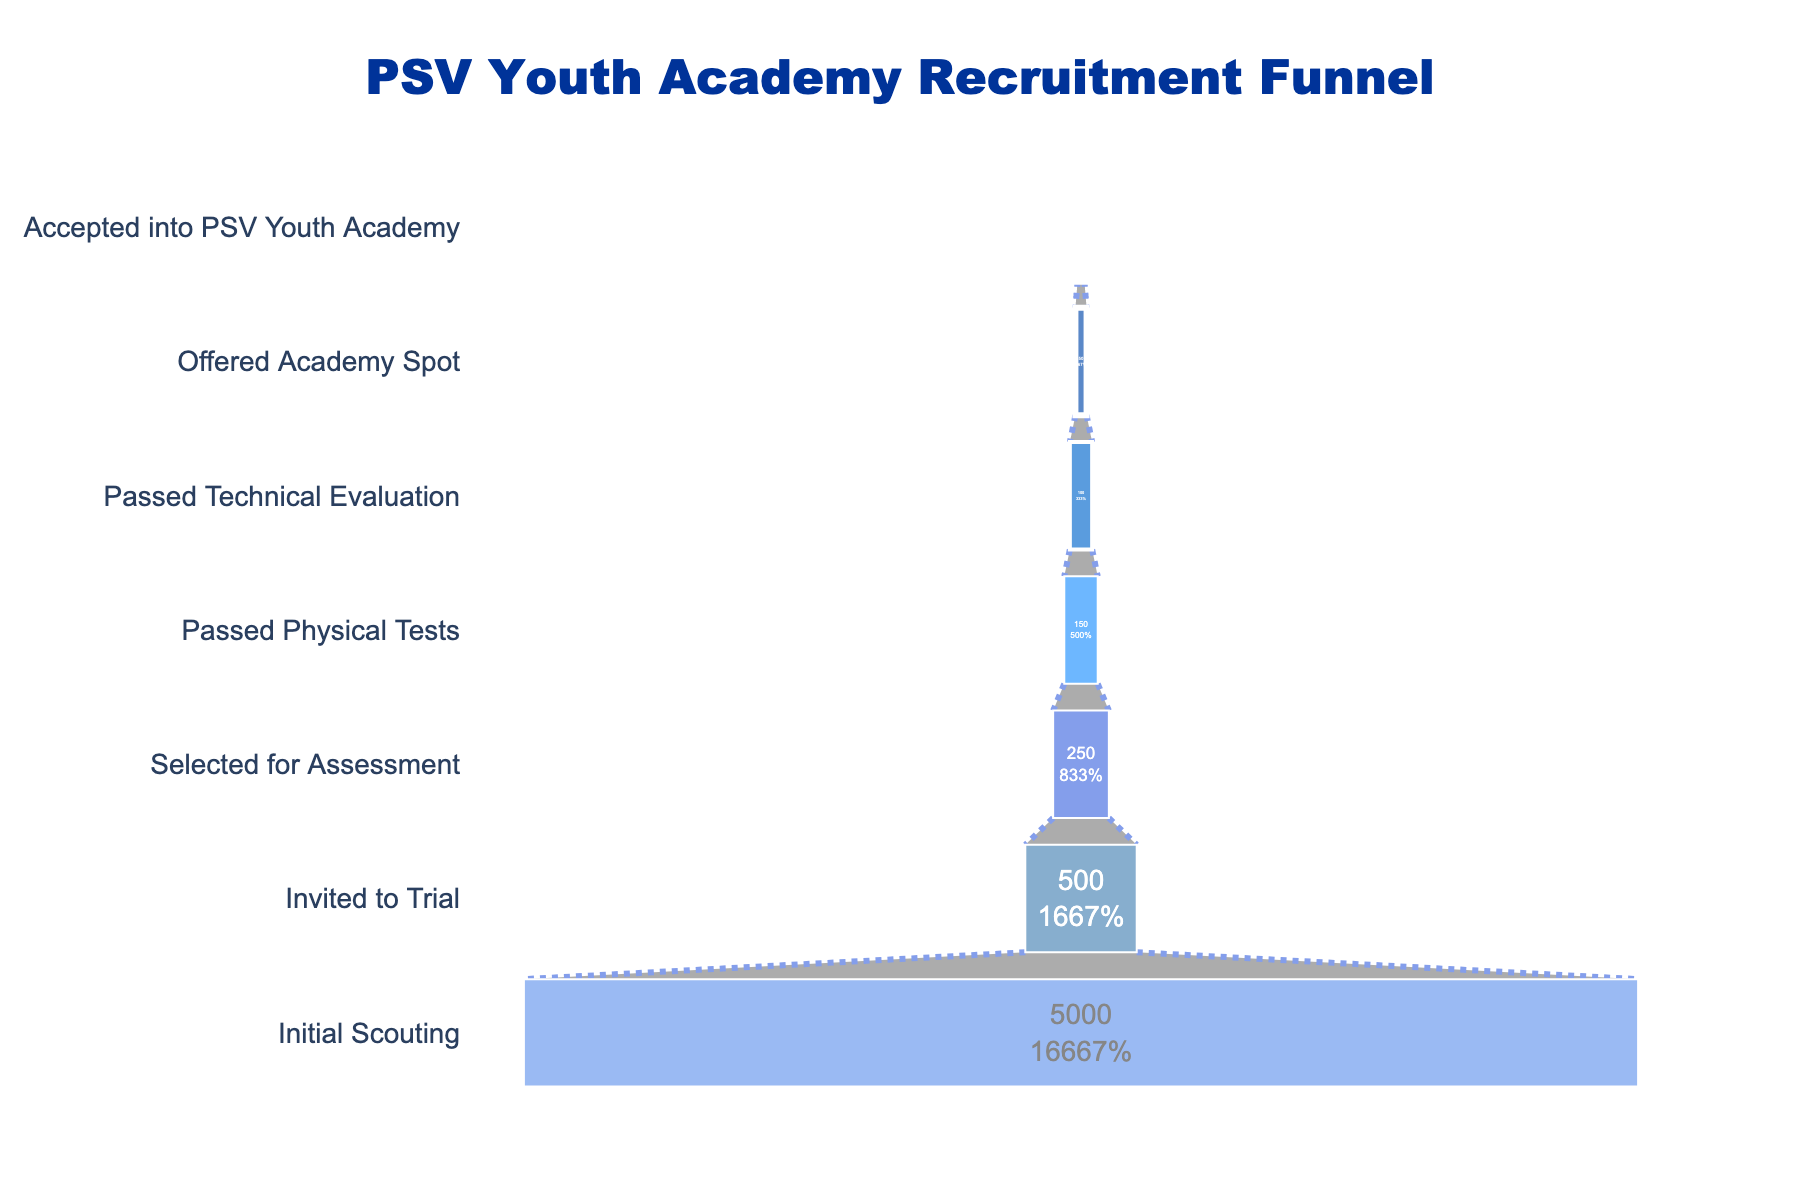What is the title of the funnel chart? The title of the funnel chart is usually displayed at the top of the plot. In this case, it is "PSV Youth Academy Recruitment Funnel".
Answer: PSV Youth Academy Recruitment Funnel How many players were initially scouted? From the funnel chart, the "Initial Scouting" stage indicates the number of players initially considered. This is shown as 5000 players.
Answer: 5000 Which stage had the greatest drop in the number of players? By comparing the differences between consecutive stages, you can identify the stage with the largest reduction. Going from "Initial Scouting" (5000) to "Invited to Trial" (500) shows a drop of 4500 players, which is the greatest drop.
Answer: Initial Scouting to Invited to Trial What percentage of scouted players are eventually accepted into the PSV Youth Academy? Calculate the percentage as (Accepted into PSV Youth Academy / Initial Scouting) * 100. This becomes (30 / 5000) * 100 = 0.6%.
Answer: 0.6% How many stages are there in the PSV recruitment process? By counting the stages listed on the vertical axis of the funnel chart, we can find there are seven stages.
Answer: 7 How many players passed the physical tests? From the funnel chart, the "Passed Physical Tests" stage indicates how many players succeeded, which is 150 players.
Answer: 150 What is the total reduction in the number of players from "Invited to Trial" to "Accepted into PSV Youth Academy"? Calculate the difference between players "Invited to Trial" (500) and those "Accepted into PSV Youth Academy" (30): 500 - 30 = 470.
Answer: 470 Compare the number of players who passed the technical evaluation to those offered an academy spot. From the funnel chart, "Passed Technical Evaluation" has 100 players, and "Offered Academy Spot" has 50 players. There are twice as many players passing the technical evaluation compared to being offered a spot.
Answer: Twice as many What proportion of players who were "Selected for Assessment" ended up accepting a spot in the PSV Youth Academy? First, find the number of players "Selected for Assessment" (250) and the number "Accepted into PSV Youth Academy" (30). The proportion is 30 / 250 = 0.12, or 12%.
Answer: 12% Which stage has the smallest number of players, and how many are there? By observing the funnel chart, the final stage "Accepted into PSV Youth Academy" has the smallest number, which is 30 players.
Answer: Accepted into PSV Youth Academy, 30 